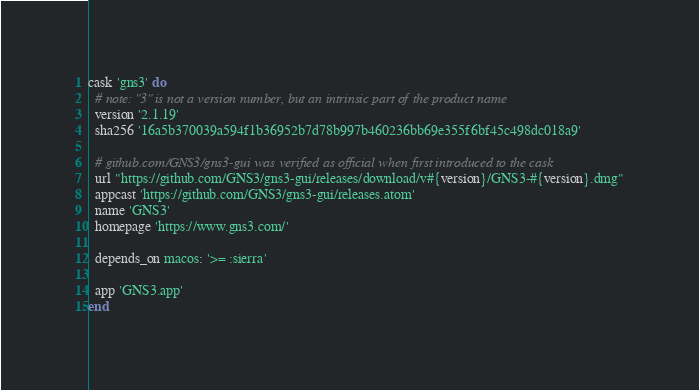Convert code to text. <code><loc_0><loc_0><loc_500><loc_500><_Ruby_>cask 'gns3' do
  # note: "3" is not a version number, but an intrinsic part of the product name
  version '2.1.19'
  sha256 '16a5b370039a594f1b36952b7d78b997b460236bb69e355f6bf45c498dc018a9'

  # github.com/GNS3/gns3-gui was verified as official when first introduced to the cask
  url "https://github.com/GNS3/gns3-gui/releases/download/v#{version}/GNS3-#{version}.dmg"
  appcast 'https://github.com/GNS3/gns3-gui/releases.atom'
  name 'GNS3'
  homepage 'https://www.gns3.com/'

  depends_on macos: '>= :sierra'

  app 'GNS3.app'
end
</code> 